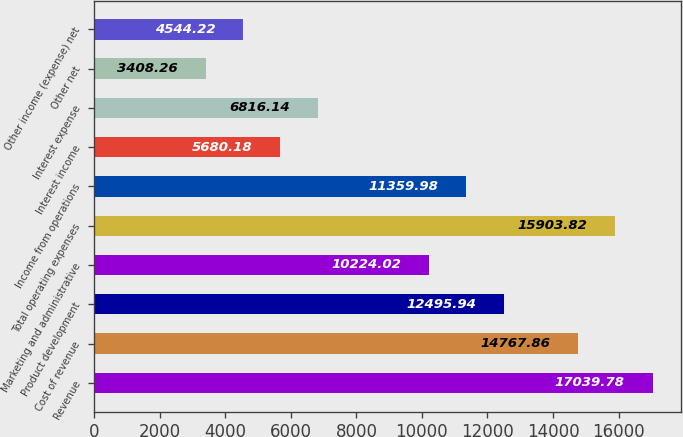<chart> <loc_0><loc_0><loc_500><loc_500><bar_chart><fcel>Revenue<fcel>Cost of revenue<fcel>Product development<fcel>Marketing and administrative<fcel>Total operating expenses<fcel>Income from operations<fcel>Interest income<fcel>Interest expense<fcel>Other net<fcel>Other income (expense) net<nl><fcel>17039.8<fcel>14767.9<fcel>12495.9<fcel>10224<fcel>15903.8<fcel>11360<fcel>5680.18<fcel>6816.14<fcel>3408.26<fcel>4544.22<nl></chart> 